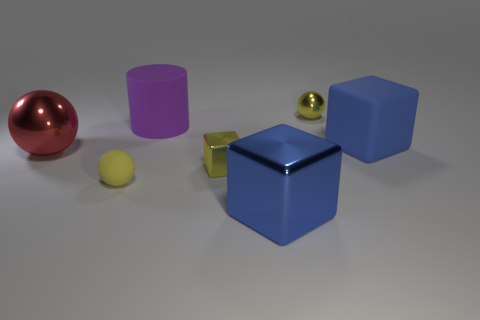There is another large cube that is the same color as the big rubber cube; what is its material?
Provide a succinct answer. Metal. Do the cylinder and the small yellow block have the same material?
Your answer should be very brief. No. What number of big blue cubes have the same material as the red ball?
Your response must be concise. 1. There is a small object that is the same material as the tiny cube; what color is it?
Make the answer very short. Yellow. The large purple rubber object is what shape?
Make the answer very short. Cylinder. There is a yellow sphere on the right side of the small rubber object; what is its material?
Provide a succinct answer. Metal. Is there another large metallic sphere of the same color as the large ball?
Make the answer very short. No. What shape is the purple matte object that is the same size as the red shiny thing?
Your answer should be very brief. Cylinder. The sphere to the right of the tiny cube is what color?
Provide a succinct answer. Yellow. Is there a tiny metal sphere that is right of the metallic thing behind the purple rubber thing?
Your answer should be very brief. No. 